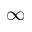<formula> <loc_0><loc_0><loc_500><loc_500>{ \infty }</formula> 